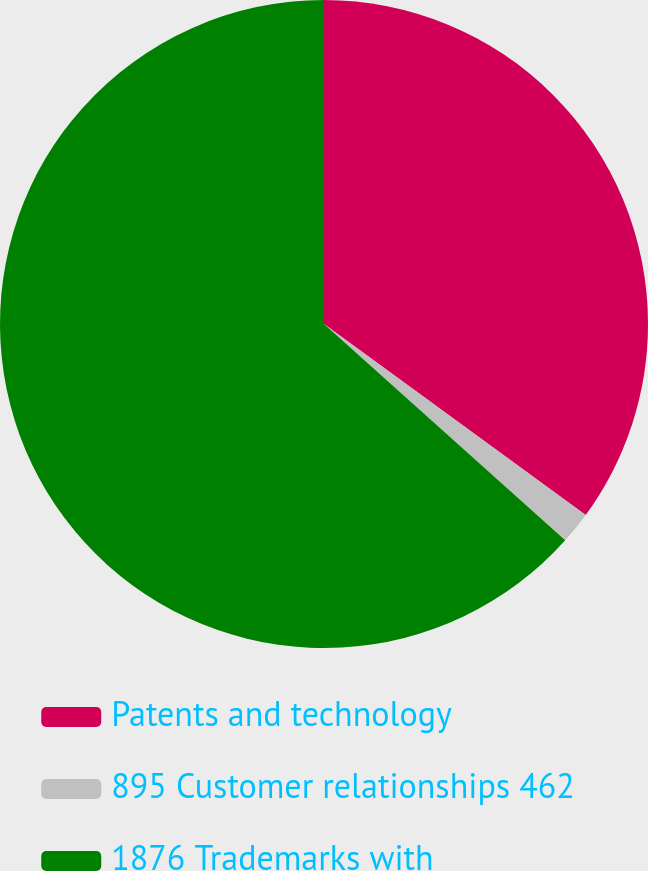Convert chart to OTSL. <chart><loc_0><loc_0><loc_500><loc_500><pie_chart><fcel>Patents and technology<fcel>895 Customer relationships 462<fcel>1876 Trademarks with<nl><fcel>35.04%<fcel>1.6%<fcel>63.37%<nl></chart> 